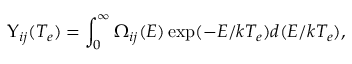Convert formula to latex. <formula><loc_0><loc_0><loc_500><loc_500>\Upsilon _ { i j } ( T _ { e } ) = \int _ { 0 } ^ { \infty } \Omega _ { i j } ( E ) \exp ( - E / k T _ { e } ) d ( E / k T _ { e } ) ,</formula> 